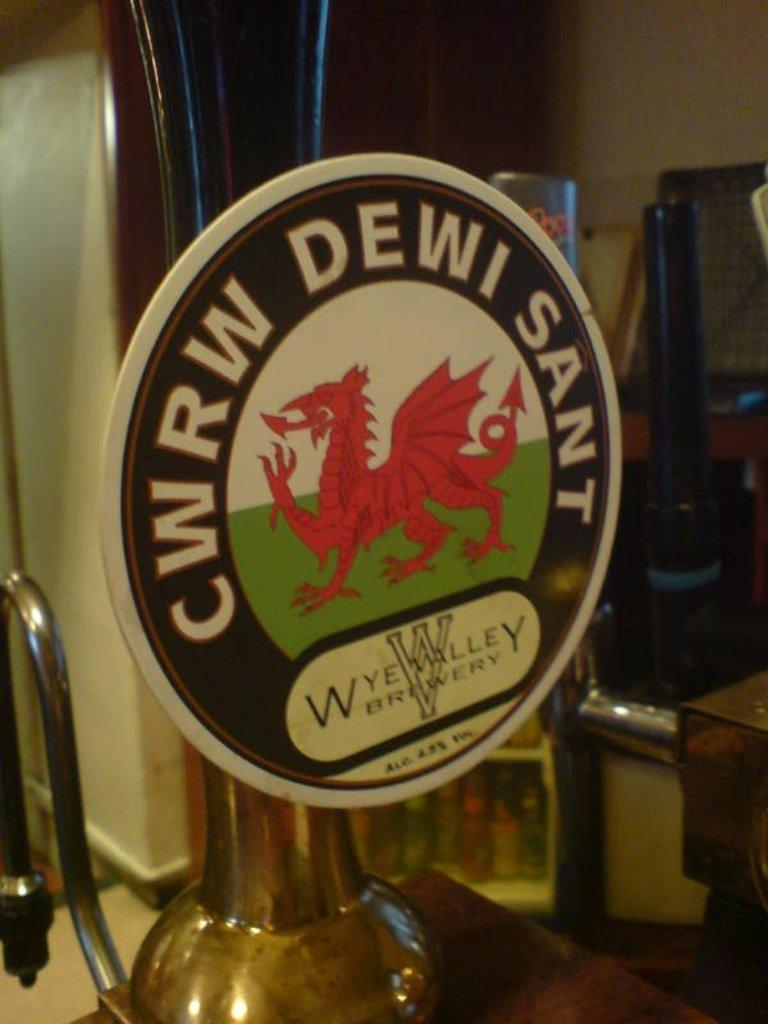Provide a one-sentence caption for the provided image. round logo for wye valley brewery that has red dragon in center. 